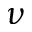Convert formula to latex. <formula><loc_0><loc_0><loc_500><loc_500>\nu</formula> 